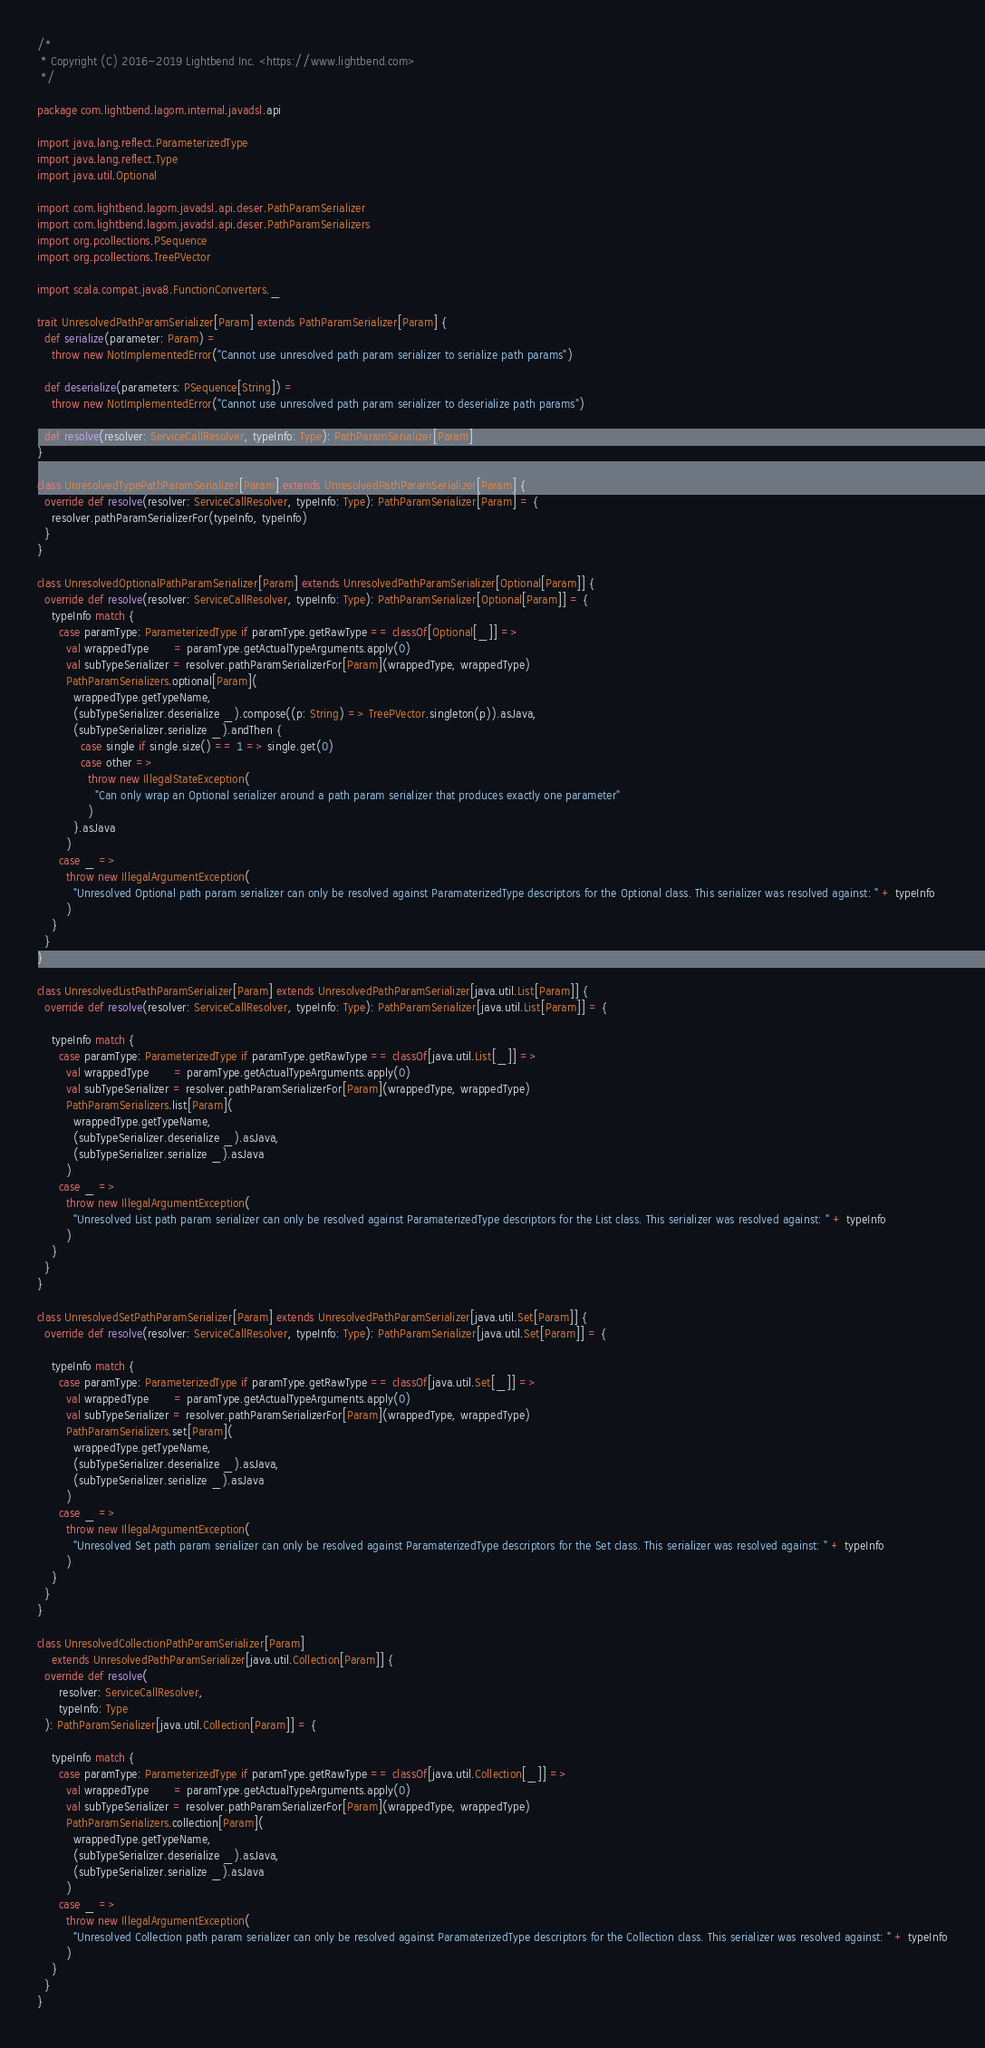<code> <loc_0><loc_0><loc_500><loc_500><_Scala_>/*
 * Copyright (C) 2016-2019 Lightbend Inc. <https://www.lightbend.com>
 */

package com.lightbend.lagom.internal.javadsl.api

import java.lang.reflect.ParameterizedType
import java.lang.reflect.Type
import java.util.Optional

import com.lightbend.lagom.javadsl.api.deser.PathParamSerializer
import com.lightbend.lagom.javadsl.api.deser.PathParamSerializers
import org.pcollections.PSequence
import org.pcollections.TreePVector

import scala.compat.java8.FunctionConverters._

trait UnresolvedPathParamSerializer[Param] extends PathParamSerializer[Param] {
  def serialize(parameter: Param) =
    throw new NotImplementedError("Cannot use unresolved path param serializer to serialize path params")

  def deserialize(parameters: PSequence[String]) =
    throw new NotImplementedError("Cannot use unresolved path param serializer to deserialize path params")

  def resolve(resolver: ServiceCallResolver, typeInfo: Type): PathParamSerializer[Param]
}

class UnresolvedTypePathParamSerializer[Param] extends UnresolvedPathParamSerializer[Param] {
  override def resolve(resolver: ServiceCallResolver, typeInfo: Type): PathParamSerializer[Param] = {
    resolver.pathParamSerializerFor(typeInfo, typeInfo)
  }
}

class UnresolvedOptionalPathParamSerializer[Param] extends UnresolvedPathParamSerializer[Optional[Param]] {
  override def resolve(resolver: ServiceCallResolver, typeInfo: Type): PathParamSerializer[Optional[Param]] = {
    typeInfo match {
      case paramType: ParameterizedType if paramType.getRawType == classOf[Optional[_]] =>
        val wrappedType       = paramType.getActualTypeArguments.apply(0)
        val subTypeSerializer = resolver.pathParamSerializerFor[Param](wrappedType, wrappedType)
        PathParamSerializers.optional[Param](
          wrappedType.getTypeName,
          (subTypeSerializer.deserialize _).compose((p: String) => TreePVector.singleton(p)).asJava,
          (subTypeSerializer.serialize _).andThen {
            case single if single.size() == 1 => single.get(0)
            case other =>
              throw new IllegalStateException(
                "Can only wrap an Optional serializer around a path param serializer that produces exactly one parameter"
              )
          }.asJava
        )
      case _ =>
        throw new IllegalArgumentException(
          "Unresolved Optional path param serializer can only be resolved against ParamaterizedType descriptors for the Optional class. This serializer was resolved against: " + typeInfo
        )
    }
  }
}

class UnresolvedListPathParamSerializer[Param] extends UnresolvedPathParamSerializer[java.util.List[Param]] {
  override def resolve(resolver: ServiceCallResolver, typeInfo: Type): PathParamSerializer[java.util.List[Param]] = {

    typeInfo match {
      case paramType: ParameterizedType if paramType.getRawType == classOf[java.util.List[_]] =>
        val wrappedType       = paramType.getActualTypeArguments.apply(0)
        val subTypeSerializer = resolver.pathParamSerializerFor[Param](wrappedType, wrappedType)
        PathParamSerializers.list[Param](
          wrappedType.getTypeName,
          (subTypeSerializer.deserialize _).asJava,
          (subTypeSerializer.serialize _).asJava
        )
      case _ =>
        throw new IllegalArgumentException(
          "Unresolved List path param serializer can only be resolved against ParamaterizedType descriptors for the List class. This serializer was resolved against: " + typeInfo
        )
    }
  }
}

class UnresolvedSetPathParamSerializer[Param] extends UnresolvedPathParamSerializer[java.util.Set[Param]] {
  override def resolve(resolver: ServiceCallResolver, typeInfo: Type): PathParamSerializer[java.util.Set[Param]] = {

    typeInfo match {
      case paramType: ParameterizedType if paramType.getRawType == classOf[java.util.Set[_]] =>
        val wrappedType       = paramType.getActualTypeArguments.apply(0)
        val subTypeSerializer = resolver.pathParamSerializerFor[Param](wrappedType, wrappedType)
        PathParamSerializers.set[Param](
          wrappedType.getTypeName,
          (subTypeSerializer.deserialize _).asJava,
          (subTypeSerializer.serialize _).asJava
        )
      case _ =>
        throw new IllegalArgumentException(
          "Unresolved Set path param serializer can only be resolved against ParamaterizedType descriptors for the Set class. This serializer was resolved against: " + typeInfo
        )
    }
  }
}

class UnresolvedCollectionPathParamSerializer[Param]
    extends UnresolvedPathParamSerializer[java.util.Collection[Param]] {
  override def resolve(
      resolver: ServiceCallResolver,
      typeInfo: Type
  ): PathParamSerializer[java.util.Collection[Param]] = {

    typeInfo match {
      case paramType: ParameterizedType if paramType.getRawType == classOf[java.util.Collection[_]] =>
        val wrappedType       = paramType.getActualTypeArguments.apply(0)
        val subTypeSerializer = resolver.pathParamSerializerFor[Param](wrappedType, wrappedType)
        PathParamSerializers.collection[Param](
          wrappedType.getTypeName,
          (subTypeSerializer.deserialize _).asJava,
          (subTypeSerializer.serialize _).asJava
        )
      case _ =>
        throw new IllegalArgumentException(
          "Unresolved Collection path param serializer can only be resolved against ParamaterizedType descriptors for the Collection class. This serializer was resolved against: " + typeInfo
        )
    }
  }
}
</code> 